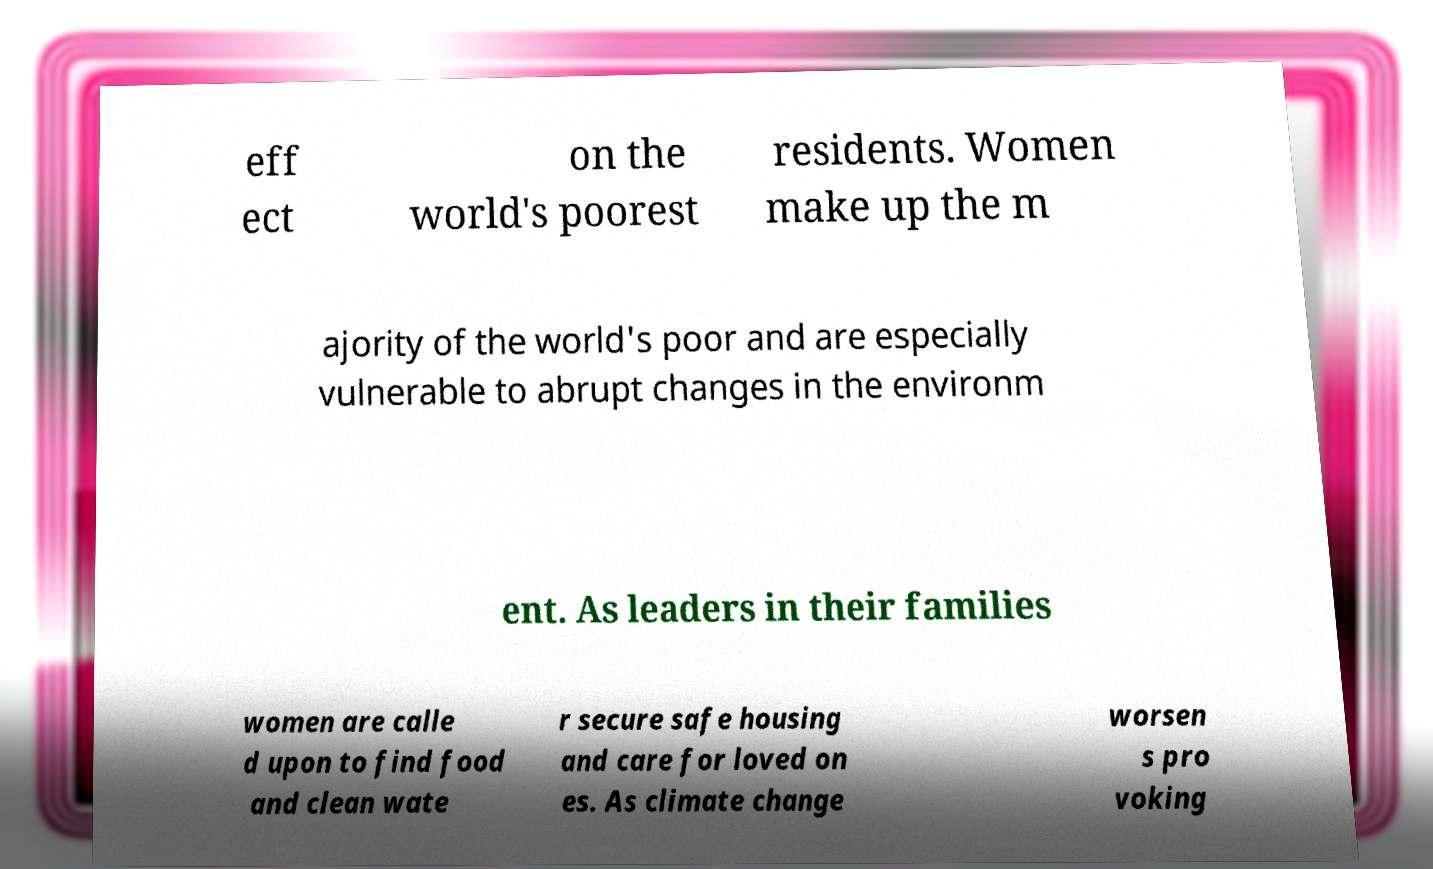What messages or text are displayed in this image? I need them in a readable, typed format. eff ect on the world's poorest residents. Women make up the m ajority of the world's poor and are especially vulnerable to abrupt changes in the environm ent. As leaders in their families women are calle d upon to find food and clean wate r secure safe housing and care for loved on es. As climate change worsen s pro voking 